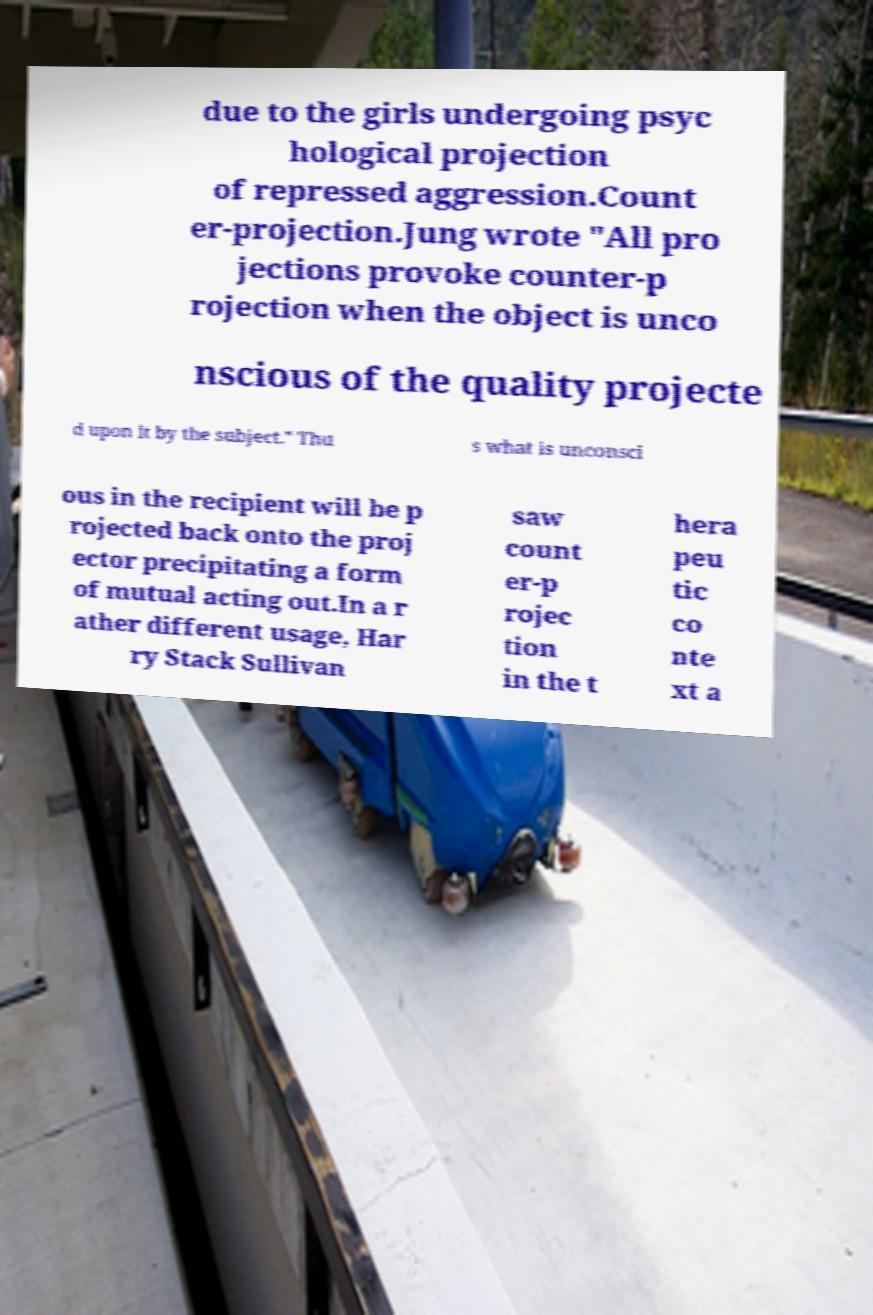Please read and relay the text visible in this image. What does it say? due to the girls undergoing psyc hological projection of repressed aggression.Count er-projection.Jung wrote "All pro jections provoke counter-p rojection when the object is unco nscious of the quality projecte d upon it by the subject." Thu s what is unconsci ous in the recipient will be p rojected back onto the proj ector precipitating a form of mutual acting out.In a r ather different usage, Har ry Stack Sullivan saw count er-p rojec tion in the t hera peu tic co nte xt a 